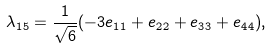Convert formula to latex. <formula><loc_0><loc_0><loc_500><loc_500>\lambda _ { 1 5 } = \frac { 1 } { \sqrt { 6 } } ( - 3 e _ { 1 1 } + e _ { 2 2 } + e _ { 3 3 } + e _ { 4 4 } ) ,</formula> 